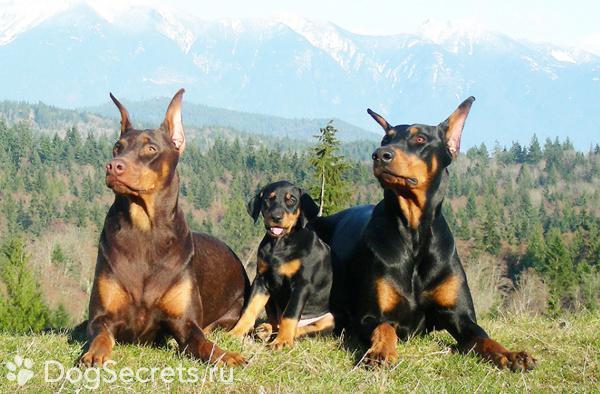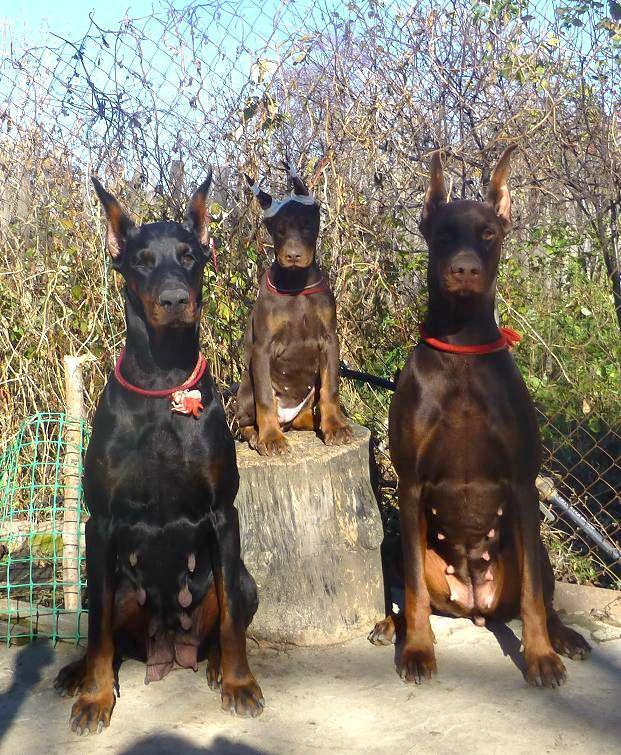The first image is the image on the left, the second image is the image on the right. Considering the images on both sides, is "Every picture has 3 dogs in it." valid? Answer yes or no. Yes. The first image is the image on the left, the second image is the image on the right. Evaluate the accuracy of this statement regarding the images: "There are three dogs exactly in each image.". Is it true? Answer yes or no. Yes. 